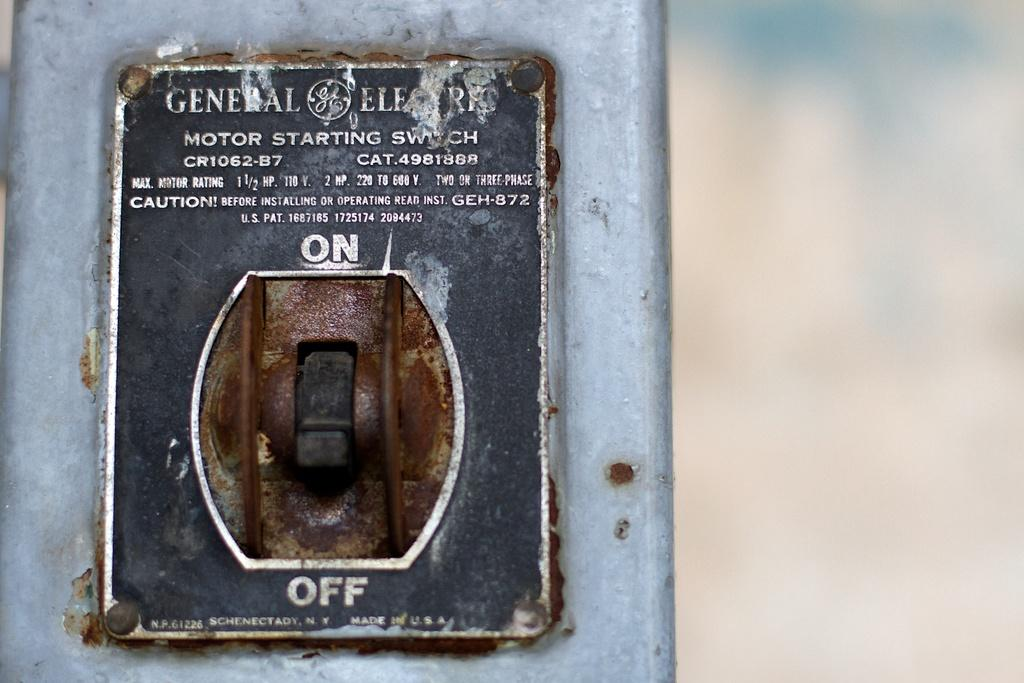<image>
Offer a succinct explanation of the picture presented. GE Motor Starting Switch is labeled on this wall toggle. 